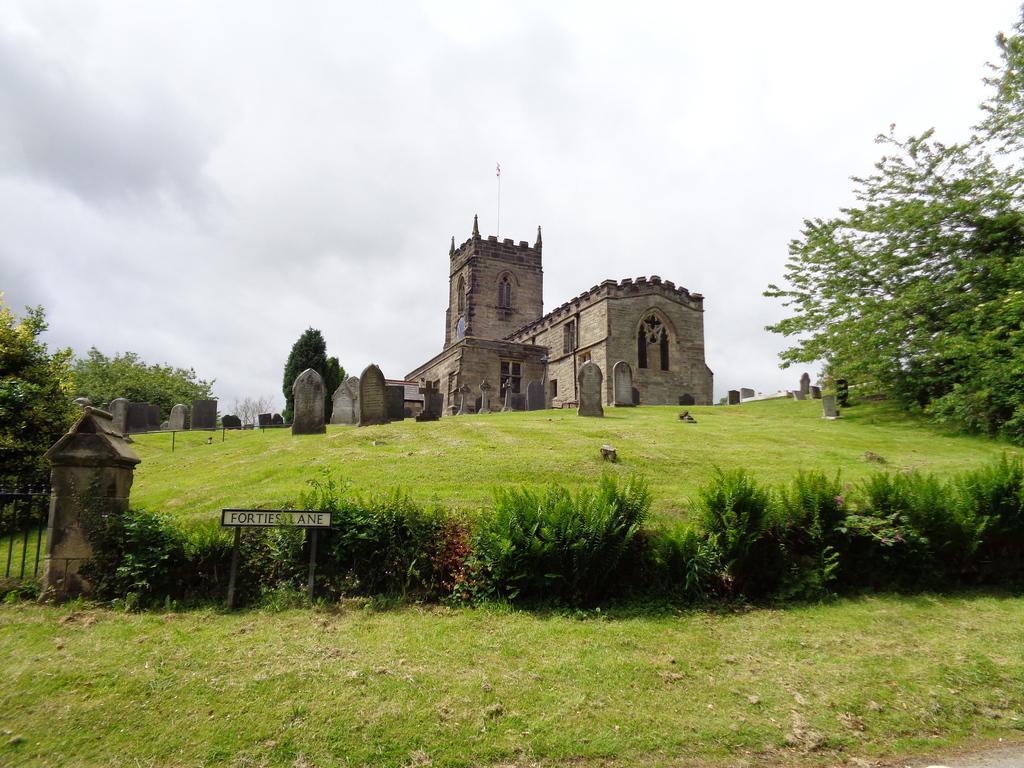Could you give a brief overview of what you see in this image? In this image, we can see a building. We can see the ground with some objects. We can also see some grass, plants and trees. We can see the black colored object on the left. We can also see the sky with clouds and a board with some text. 